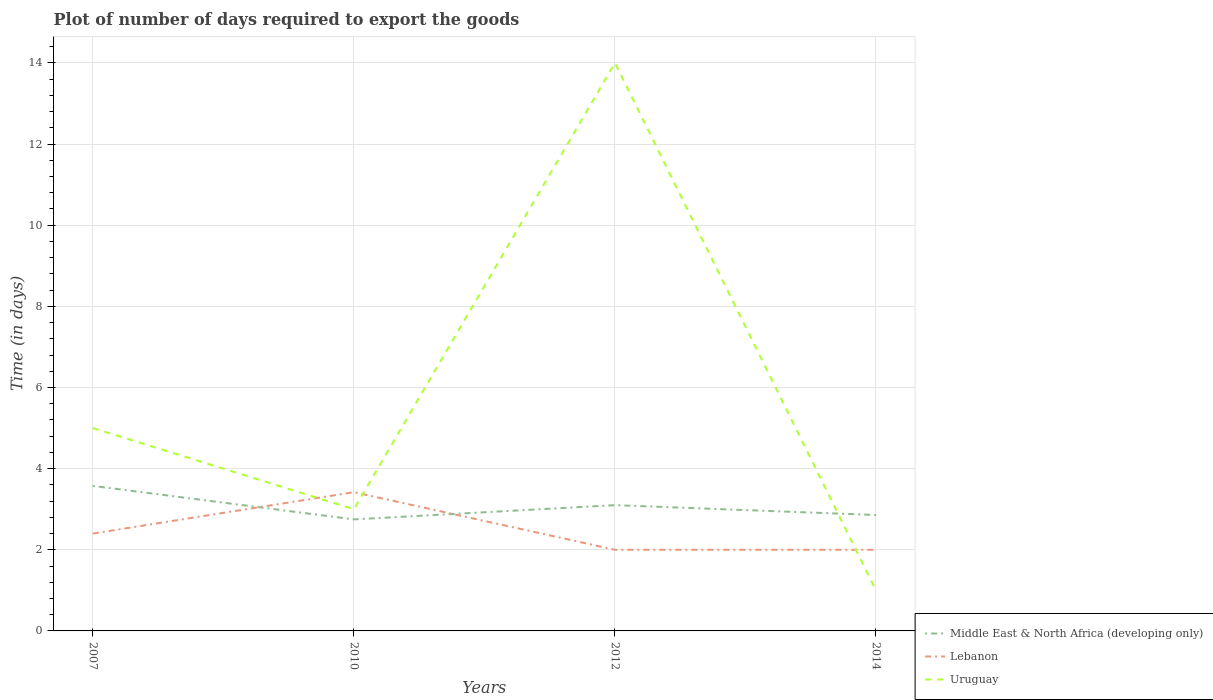Does the line corresponding to Lebanon intersect with the line corresponding to Uruguay?
Keep it short and to the point. Yes. Is the number of lines equal to the number of legend labels?
Ensure brevity in your answer.  Yes. Across all years, what is the maximum time required to export goods in Lebanon?
Make the answer very short. 2. In which year was the time required to export goods in Uruguay maximum?
Keep it short and to the point. 2014. What is the total time required to export goods in Uruguay in the graph?
Your answer should be compact. 2. What is the difference between the highest and the second highest time required to export goods in Uruguay?
Keep it short and to the point. 13. How many years are there in the graph?
Offer a very short reply. 4. Are the values on the major ticks of Y-axis written in scientific E-notation?
Offer a very short reply. No. Does the graph contain any zero values?
Your answer should be very brief. No. Does the graph contain grids?
Your answer should be very brief. Yes. Where does the legend appear in the graph?
Offer a terse response. Bottom right. How many legend labels are there?
Give a very brief answer. 3. How are the legend labels stacked?
Provide a short and direct response. Vertical. What is the title of the graph?
Offer a terse response. Plot of number of days required to export the goods. Does "Ecuador" appear as one of the legend labels in the graph?
Offer a very short reply. No. What is the label or title of the Y-axis?
Provide a short and direct response. Time (in days). What is the Time (in days) in Middle East & North Africa (developing only) in 2007?
Keep it short and to the point. 3.58. What is the Time (in days) of Uruguay in 2007?
Offer a terse response. 5. What is the Time (in days) in Middle East & North Africa (developing only) in 2010?
Your answer should be very brief. 2.75. What is the Time (in days) in Lebanon in 2010?
Offer a very short reply. 3.42. What is the Time (in days) in Lebanon in 2012?
Your answer should be very brief. 2. What is the Time (in days) of Middle East & North Africa (developing only) in 2014?
Your answer should be very brief. 2.86. What is the Time (in days) in Lebanon in 2014?
Provide a short and direct response. 2. Across all years, what is the maximum Time (in days) in Middle East & North Africa (developing only)?
Keep it short and to the point. 3.58. Across all years, what is the maximum Time (in days) in Lebanon?
Ensure brevity in your answer.  3.42. Across all years, what is the minimum Time (in days) in Middle East & North Africa (developing only)?
Make the answer very short. 2.75. What is the total Time (in days) in Middle East & North Africa (developing only) in the graph?
Your response must be concise. 12.28. What is the total Time (in days) of Lebanon in the graph?
Ensure brevity in your answer.  9.82. What is the total Time (in days) in Uruguay in the graph?
Your response must be concise. 23. What is the difference between the Time (in days) in Middle East & North Africa (developing only) in 2007 and that in 2010?
Provide a succinct answer. 0.83. What is the difference between the Time (in days) of Lebanon in 2007 and that in 2010?
Your answer should be compact. -1.02. What is the difference between the Time (in days) in Middle East & North Africa (developing only) in 2007 and that in 2012?
Provide a succinct answer. 0.47. What is the difference between the Time (in days) of Lebanon in 2007 and that in 2012?
Keep it short and to the point. 0.4. What is the difference between the Time (in days) of Uruguay in 2007 and that in 2012?
Provide a short and direct response. -9. What is the difference between the Time (in days) of Middle East & North Africa (developing only) in 2007 and that in 2014?
Offer a very short reply. 0.72. What is the difference between the Time (in days) in Middle East & North Africa (developing only) in 2010 and that in 2012?
Your response must be concise. -0.35. What is the difference between the Time (in days) in Lebanon in 2010 and that in 2012?
Offer a terse response. 1.42. What is the difference between the Time (in days) of Middle East & North Africa (developing only) in 2010 and that in 2014?
Offer a very short reply. -0.11. What is the difference between the Time (in days) of Lebanon in 2010 and that in 2014?
Ensure brevity in your answer.  1.42. What is the difference between the Time (in days) in Middle East & North Africa (developing only) in 2012 and that in 2014?
Ensure brevity in your answer.  0.24. What is the difference between the Time (in days) in Lebanon in 2012 and that in 2014?
Offer a very short reply. 0. What is the difference between the Time (in days) of Middle East & North Africa (developing only) in 2007 and the Time (in days) of Lebanon in 2010?
Your answer should be compact. 0.15. What is the difference between the Time (in days) of Middle East & North Africa (developing only) in 2007 and the Time (in days) of Uruguay in 2010?
Provide a short and direct response. 0.57. What is the difference between the Time (in days) of Lebanon in 2007 and the Time (in days) of Uruguay in 2010?
Give a very brief answer. -0.6. What is the difference between the Time (in days) in Middle East & North Africa (developing only) in 2007 and the Time (in days) in Lebanon in 2012?
Your answer should be compact. 1.57. What is the difference between the Time (in days) of Middle East & North Africa (developing only) in 2007 and the Time (in days) of Uruguay in 2012?
Your answer should be compact. -10.43. What is the difference between the Time (in days) in Middle East & North Africa (developing only) in 2007 and the Time (in days) in Lebanon in 2014?
Make the answer very short. 1.57. What is the difference between the Time (in days) of Middle East & North Africa (developing only) in 2007 and the Time (in days) of Uruguay in 2014?
Your answer should be very brief. 2.58. What is the difference between the Time (in days) of Lebanon in 2007 and the Time (in days) of Uruguay in 2014?
Provide a short and direct response. 1.4. What is the difference between the Time (in days) in Middle East & North Africa (developing only) in 2010 and the Time (in days) in Lebanon in 2012?
Give a very brief answer. 0.75. What is the difference between the Time (in days) of Middle East & North Africa (developing only) in 2010 and the Time (in days) of Uruguay in 2012?
Make the answer very short. -11.25. What is the difference between the Time (in days) of Lebanon in 2010 and the Time (in days) of Uruguay in 2012?
Your answer should be compact. -10.58. What is the difference between the Time (in days) in Middle East & North Africa (developing only) in 2010 and the Time (in days) in Lebanon in 2014?
Offer a terse response. 0.75. What is the difference between the Time (in days) in Middle East & North Africa (developing only) in 2010 and the Time (in days) in Uruguay in 2014?
Make the answer very short. 1.75. What is the difference between the Time (in days) of Lebanon in 2010 and the Time (in days) of Uruguay in 2014?
Make the answer very short. 2.42. What is the difference between the Time (in days) of Middle East & North Africa (developing only) in 2012 and the Time (in days) of Uruguay in 2014?
Your response must be concise. 2.1. What is the difference between the Time (in days) in Lebanon in 2012 and the Time (in days) in Uruguay in 2014?
Keep it short and to the point. 1. What is the average Time (in days) in Middle East & North Africa (developing only) per year?
Provide a short and direct response. 3.07. What is the average Time (in days) of Lebanon per year?
Ensure brevity in your answer.  2.46. What is the average Time (in days) in Uruguay per year?
Your answer should be very brief. 5.75. In the year 2007, what is the difference between the Time (in days) in Middle East & North Africa (developing only) and Time (in days) in Lebanon?
Your answer should be compact. 1.18. In the year 2007, what is the difference between the Time (in days) of Middle East & North Africa (developing only) and Time (in days) of Uruguay?
Offer a very short reply. -1.43. In the year 2010, what is the difference between the Time (in days) of Middle East & North Africa (developing only) and Time (in days) of Lebanon?
Ensure brevity in your answer.  -0.67. In the year 2010, what is the difference between the Time (in days) of Middle East & North Africa (developing only) and Time (in days) of Uruguay?
Give a very brief answer. -0.25. In the year 2010, what is the difference between the Time (in days) of Lebanon and Time (in days) of Uruguay?
Your response must be concise. 0.42. In the year 2012, what is the difference between the Time (in days) of Middle East & North Africa (developing only) and Time (in days) of Lebanon?
Your response must be concise. 1.1. In the year 2012, what is the difference between the Time (in days) in Middle East & North Africa (developing only) and Time (in days) in Uruguay?
Keep it short and to the point. -10.9. In the year 2014, what is the difference between the Time (in days) of Middle East & North Africa (developing only) and Time (in days) of Lebanon?
Provide a succinct answer. 0.86. In the year 2014, what is the difference between the Time (in days) of Middle East & North Africa (developing only) and Time (in days) of Uruguay?
Give a very brief answer. 1.86. In the year 2014, what is the difference between the Time (in days) of Lebanon and Time (in days) of Uruguay?
Offer a very short reply. 1. What is the ratio of the Time (in days) in Middle East & North Africa (developing only) in 2007 to that in 2010?
Offer a very short reply. 1.3. What is the ratio of the Time (in days) of Lebanon in 2007 to that in 2010?
Your response must be concise. 0.7. What is the ratio of the Time (in days) in Uruguay in 2007 to that in 2010?
Your answer should be compact. 1.67. What is the ratio of the Time (in days) in Middle East & North Africa (developing only) in 2007 to that in 2012?
Ensure brevity in your answer.  1.15. What is the ratio of the Time (in days) of Lebanon in 2007 to that in 2012?
Provide a short and direct response. 1.2. What is the ratio of the Time (in days) of Uruguay in 2007 to that in 2012?
Offer a terse response. 0.36. What is the ratio of the Time (in days) in Middle East & North Africa (developing only) in 2007 to that in 2014?
Give a very brief answer. 1.25. What is the ratio of the Time (in days) in Lebanon in 2007 to that in 2014?
Keep it short and to the point. 1.2. What is the ratio of the Time (in days) in Uruguay in 2007 to that in 2014?
Your answer should be compact. 5. What is the ratio of the Time (in days) in Middle East & North Africa (developing only) in 2010 to that in 2012?
Your answer should be compact. 0.89. What is the ratio of the Time (in days) in Lebanon in 2010 to that in 2012?
Ensure brevity in your answer.  1.71. What is the ratio of the Time (in days) of Uruguay in 2010 to that in 2012?
Provide a succinct answer. 0.21. What is the ratio of the Time (in days) in Middle East & North Africa (developing only) in 2010 to that in 2014?
Offer a terse response. 0.96. What is the ratio of the Time (in days) of Lebanon in 2010 to that in 2014?
Keep it short and to the point. 1.71. What is the ratio of the Time (in days) of Uruguay in 2010 to that in 2014?
Your response must be concise. 3. What is the ratio of the Time (in days) in Middle East & North Africa (developing only) in 2012 to that in 2014?
Your answer should be compact. 1.08. What is the ratio of the Time (in days) of Lebanon in 2012 to that in 2014?
Offer a very short reply. 1. What is the ratio of the Time (in days) in Uruguay in 2012 to that in 2014?
Your answer should be very brief. 14. What is the difference between the highest and the second highest Time (in days) of Middle East & North Africa (developing only)?
Keep it short and to the point. 0.47. What is the difference between the highest and the lowest Time (in days) of Middle East & North Africa (developing only)?
Your answer should be compact. 0.83. What is the difference between the highest and the lowest Time (in days) in Lebanon?
Your answer should be very brief. 1.42. What is the difference between the highest and the lowest Time (in days) in Uruguay?
Your response must be concise. 13. 